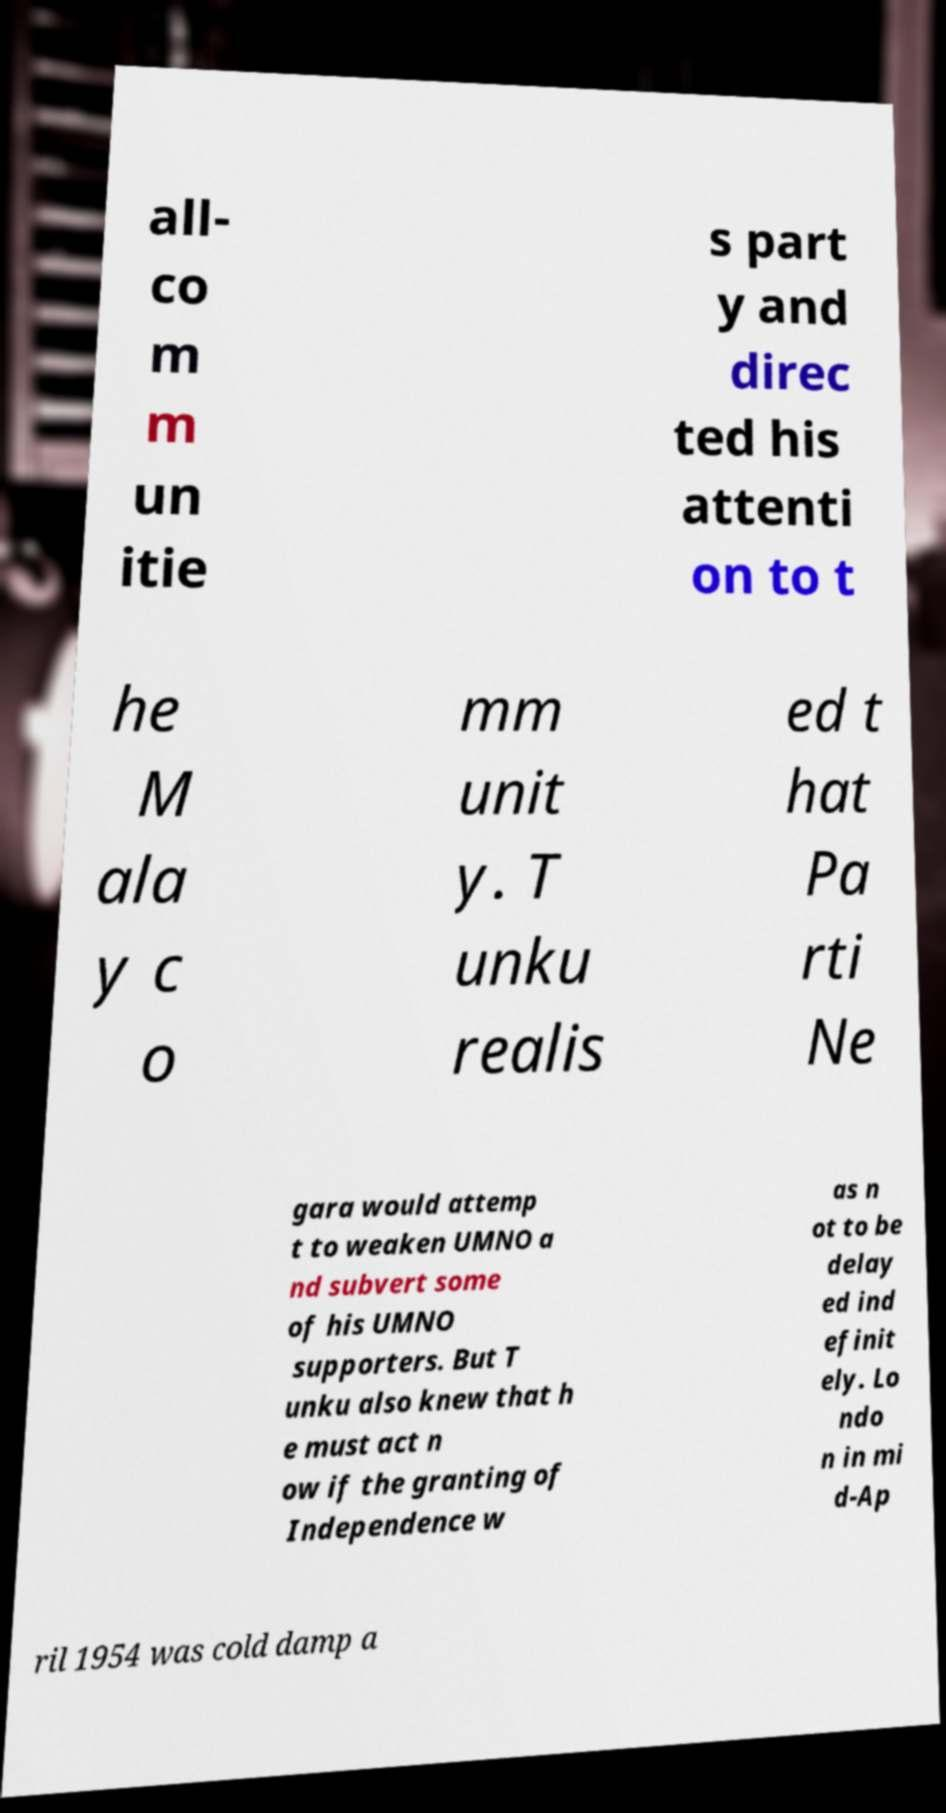Could you assist in decoding the text presented in this image and type it out clearly? all- co m m un itie s part y and direc ted his attenti on to t he M ala y c o mm unit y. T unku realis ed t hat Pa rti Ne gara would attemp t to weaken UMNO a nd subvert some of his UMNO supporters. But T unku also knew that h e must act n ow if the granting of Independence w as n ot to be delay ed ind efinit ely. Lo ndo n in mi d-Ap ril 1954 was cold damp a 